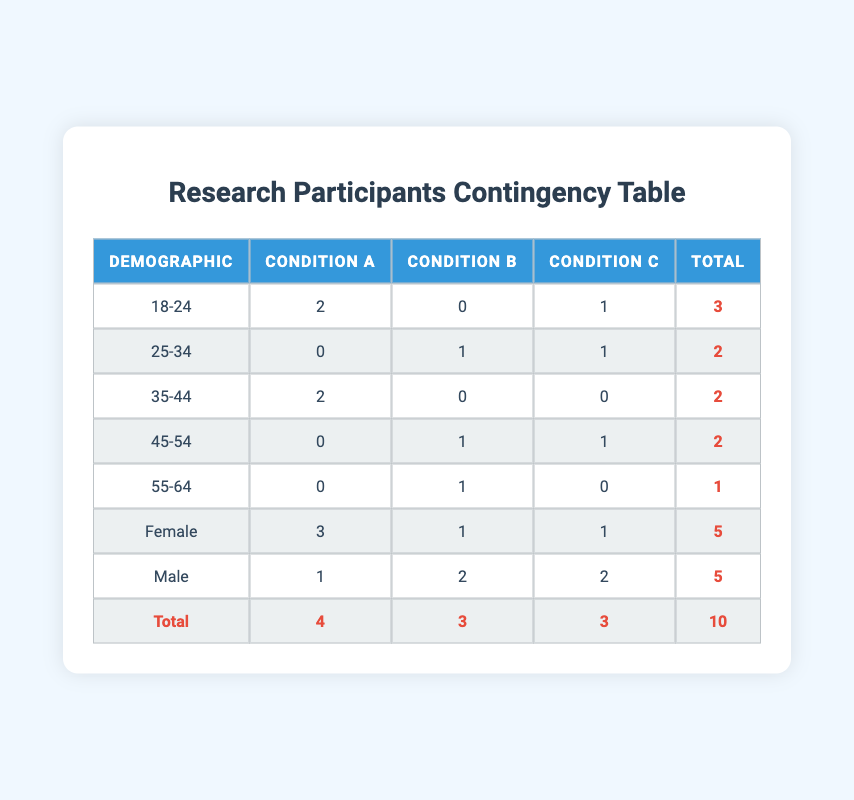What is the total number of participants who preferred Condition A? To find the total number of participants who preferred Condition A, look at the "Condition A" column and sum the values. The values are 2 (for age 18-24), 0 (for age 25-34), 2 (for age 35-44), 0 (for age 45-54), and 0 (for age 55-64). Adding these gives 2 + 0 + 2 + 0 + 0 = 4.
Answer: 4 How many males preferred Condition B? To determine how many males preferred Condition B, reference the row labeled "Male" in the "Condition B" column. The value there is 2, which represents the total number of male participants who chose Condition B.
Answer: 2 Is there any age group that preferred all conditions equally? By examining the table, we can see that no age group has a count greater than 1 for all three conditions. The maximum is 2 for Condition A and zero for Conditions B and C in age groups, indicating that no age group preferred all conditions equally.
Answer: No What is the difference in total female and male participants? First, we find the total number of female participants, which is 5, and the total number of male participants, which is also 5. To find the difference, we calculate 5 - 5 = 0.
Answer: 0 Which age group had the highest preference for Condition C? By looking at the "Condition C" column for each age group, the values are 1 (18-24), 1 (25-34), 0 (35-44), 1 (45-54), and 0 (55-64). The maximum value is 1, which appears in three different age groups (18-24, 25-34, and 45-54). Since they are equal, there is no single age group with the highest preference.
Answer: 18-24, 25-34, and 45-54 (all equal) What is the total number of participants across all conditions? The total number of participants is provided in the last row labeled "Total," which sums up the values for each condition: 4 (Condition A) + 3 (Condition B) + 3 (Condition C) = 10.
Answer: 10 In which condition is there the least number of participants? Examining the totals across the columns for Conditions A, B, and C, the numbers are 4, 3, and 3. The lowest value is 3, which corresponds to both Condition B and Condition C, indicating a tie for the least number of participants.
Answer: Condition B and Condition C If we were to calculate the average preference for each condition, what would that be? To find the average preference for each condition, we first need to sum up the participants for each condition: 4 (Condition A), 3 (Condition B), 3 (Condition C). Then we divide by the total number of participants, which is 10. The average for Condition A is 4/10 = 0.4, for Condition B is 3/10 = 0.3, and for Condition C is also 3/10 = 0.3.
Answer: Condition A = 0.4, Condition B = 0.3, Condition C = 0.3 